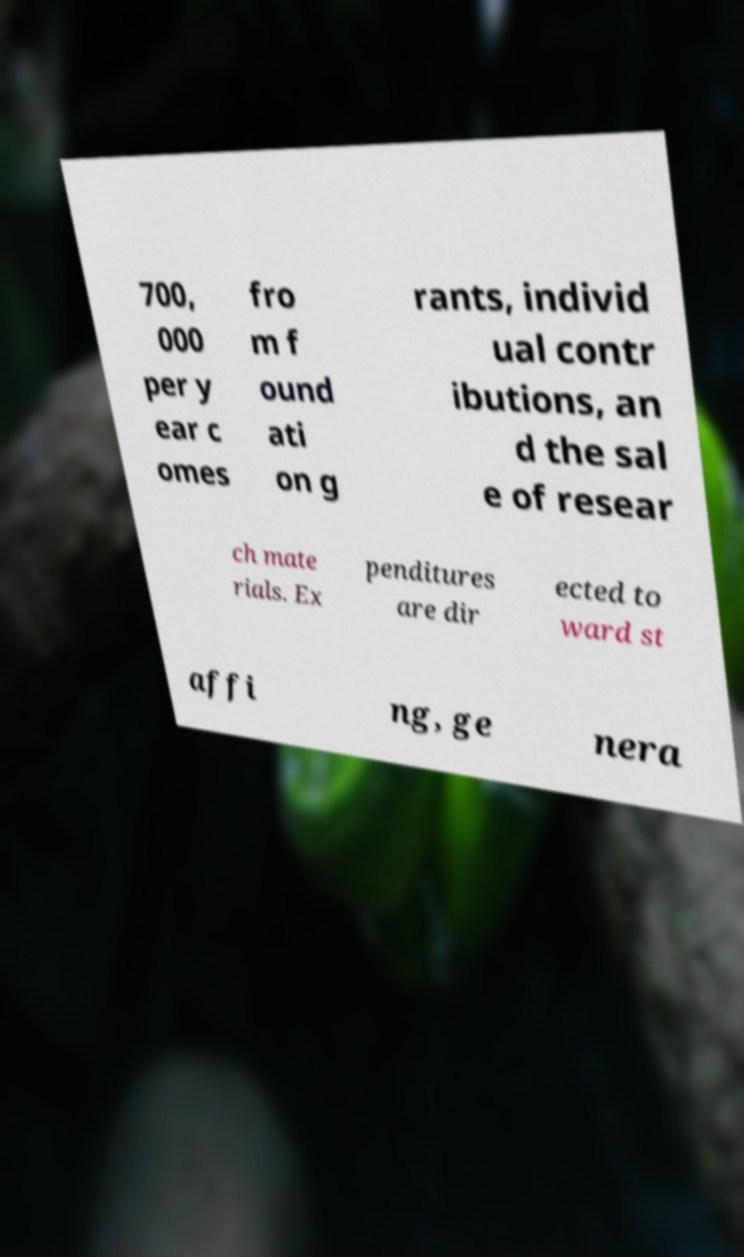For documentation purposes, I need the text within this image transcribed. Could you provide that? 700, 000 per y ear c omes fro m f ound ati on g rants, individ ual contr ibutions, an d the sal e of resear ch mate rials. Ex penditures are dir ected to ward st affi ng, ge nera 